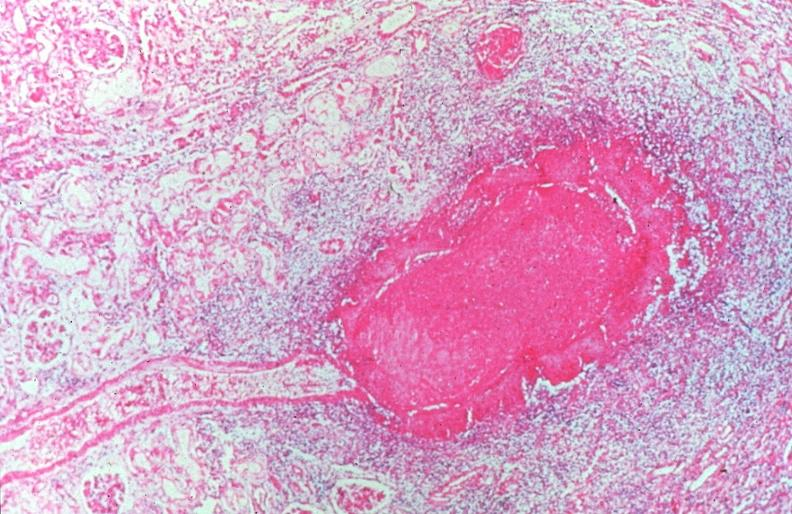does case of peritonitis slide show vasculitis, polyarteritis nodosa?
Answer the question using a single word or phrase. No 